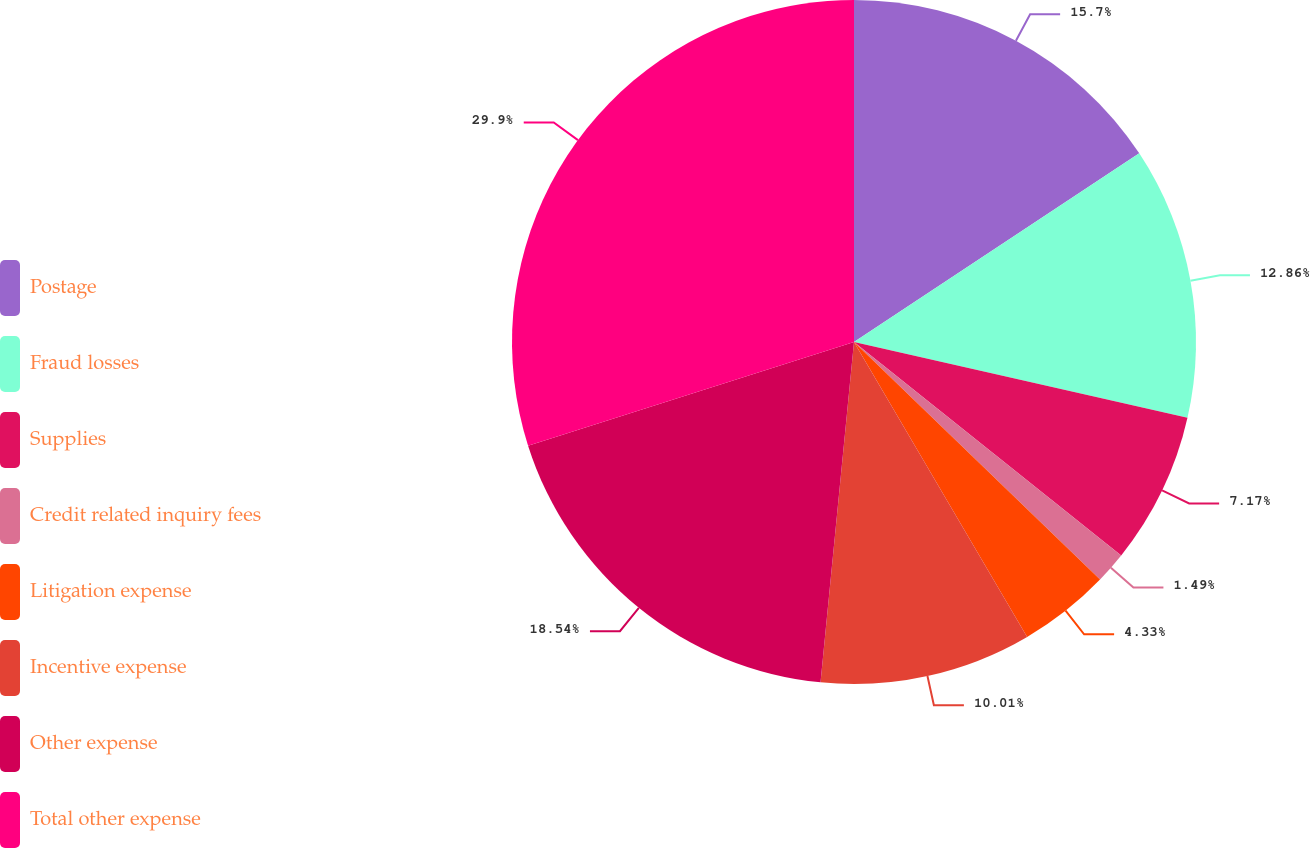<chart> <loc_0><loc_0><loc_500><loc_500><pie_chart><fcel>Postage<fcel>Fraud losses<fcel>Supplies<fcel>Credit related inquiry fees<fcel>Litigation expense<fcel>Incentive expense<fcel>Other expense<fcel>Total other expense<nl><fcel>15.7%<fcel>12.86%<fcel>7.17%<fcel>1.49%<fcel>4.33%<fcel>10.01%<fcel>18.54%<fcel>29.9%<nl></chart> 